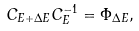Convert formula to latex. <formula><loc_0><loc_0><loc_500><loc_500>C _ { E + \Delta E } C _ { E } ^ { - 1 } = \Phi _ { \Delta E } ,</formula> 